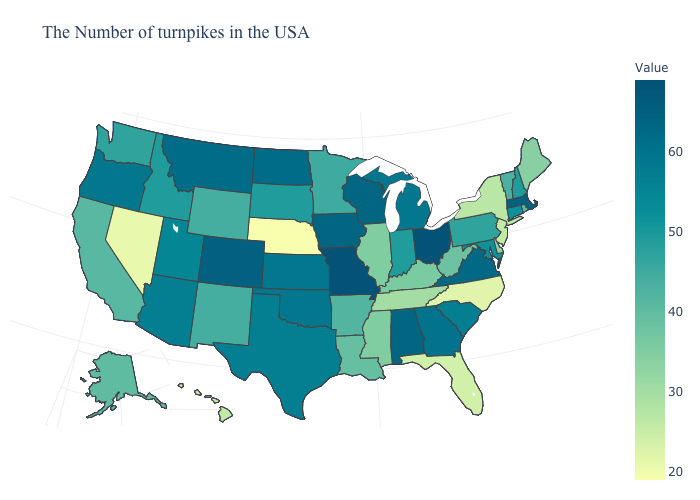Among the states that border Texas , does Oklahoma have the highest value?
Write a very short answer. Yes. Does Wyoming have the highest value in the USA?
Give a very brief answer. No. Does Rhode Island have a lower value than Maine?
Quick response, please. No. Which states have the lowest value in the West?
Answer briefly. Nevada. Among the states that border California , which have the highest value?
Answer briefly. Oregon. 